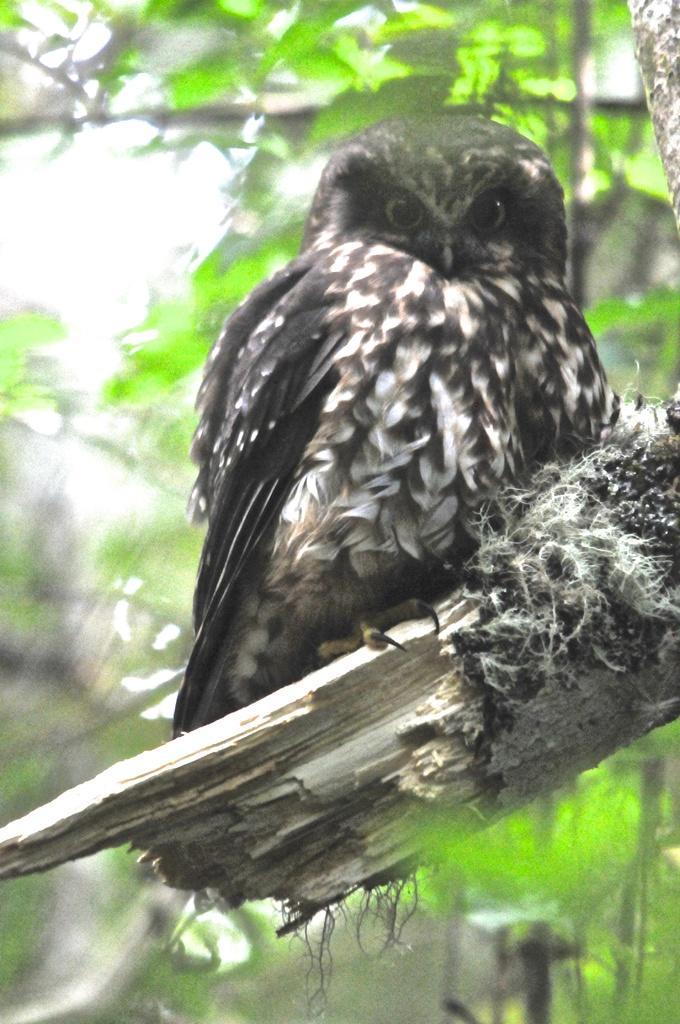Please provide a concise description of this image. In the front of the image there is a bird and branch. In the background of the image it is blurry. 